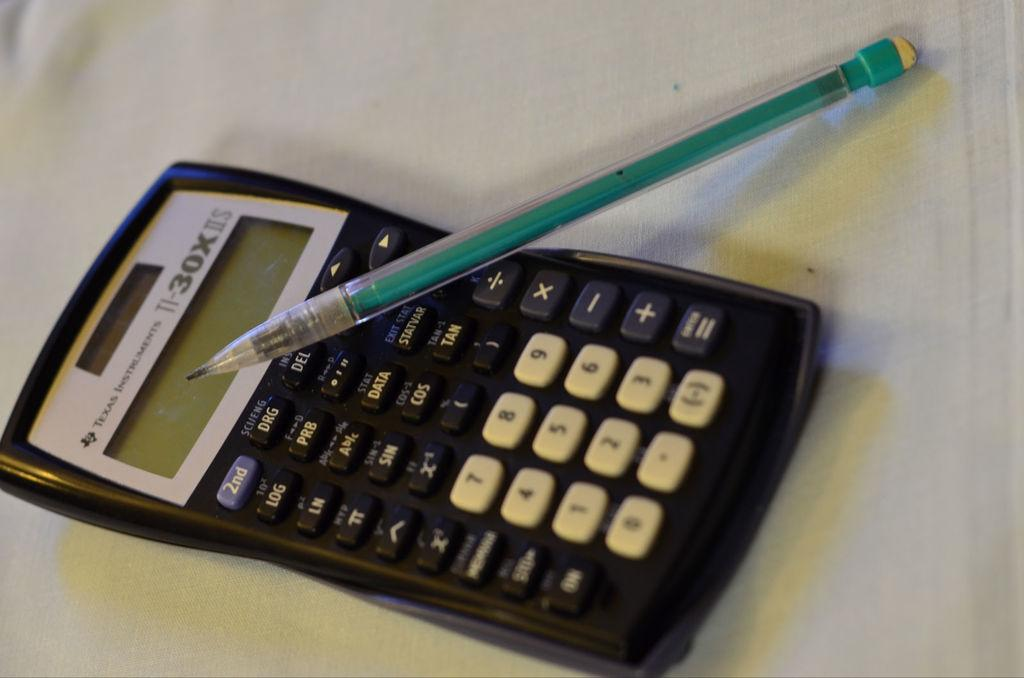<image>
Relay a brief, clear account of the picture shown. A Texas Instruments calculator with a green pencil on top of it. 